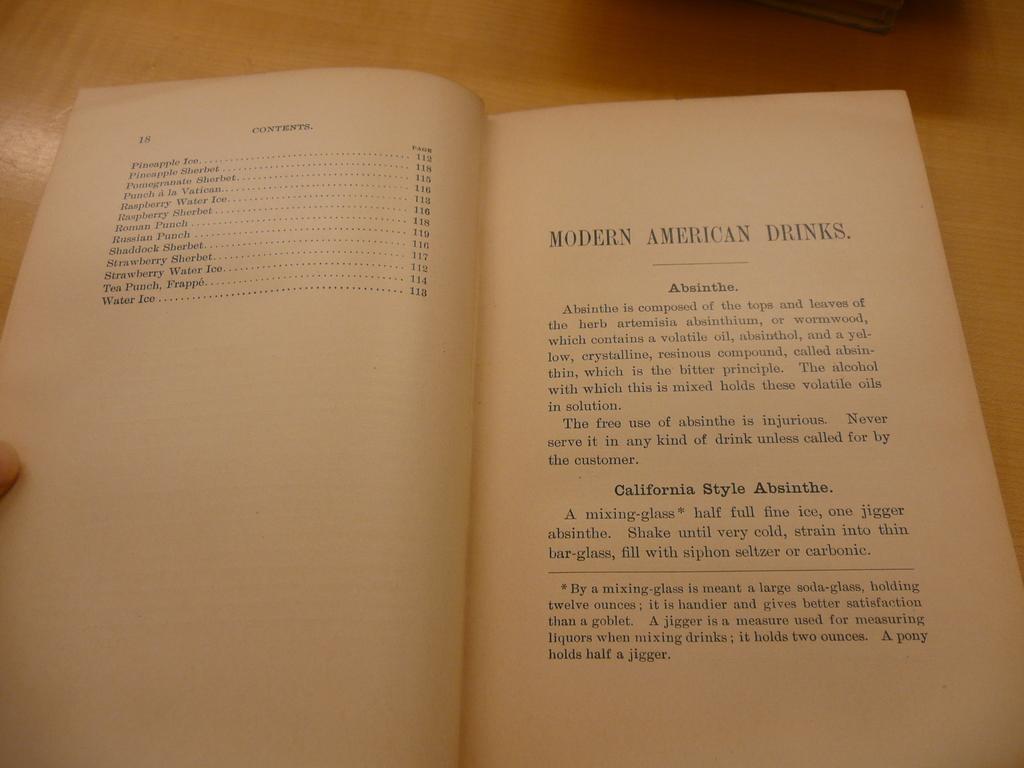What kind of absinthe is listed on the page?
Provide a succinct answer. California style. 